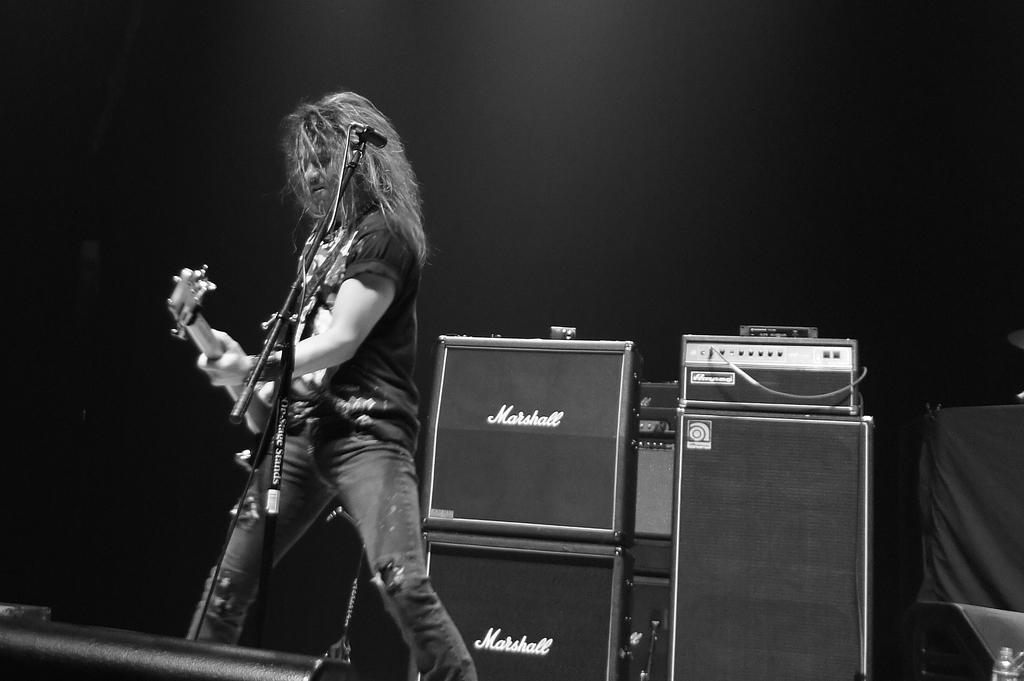What does it say on the mic stand?
Provide a succinct answer. Marshall. 